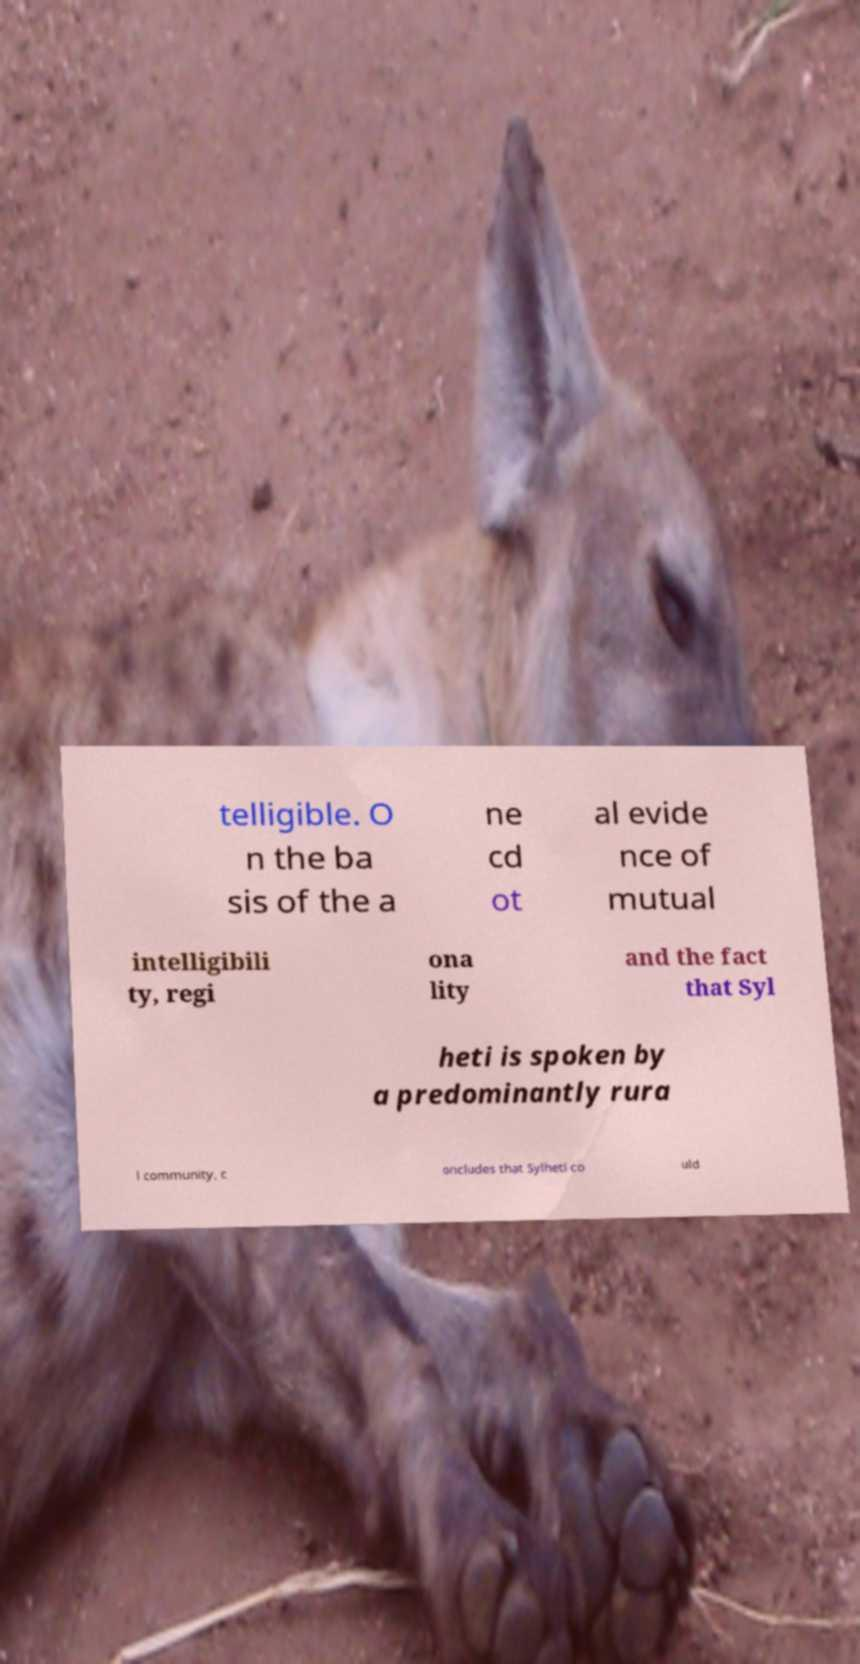Can you read and provide the text displayed in the image?This photo seems to have some interesting text. Can you extract and type it out for me? telligible. O n the ba sis of the a ne cd ot al evide nce of mutual intelligibili ty, regi ona lity and the fact that Syl heti is spoken by a predominantly rura l community, c oncludes that Sylheti co uld 